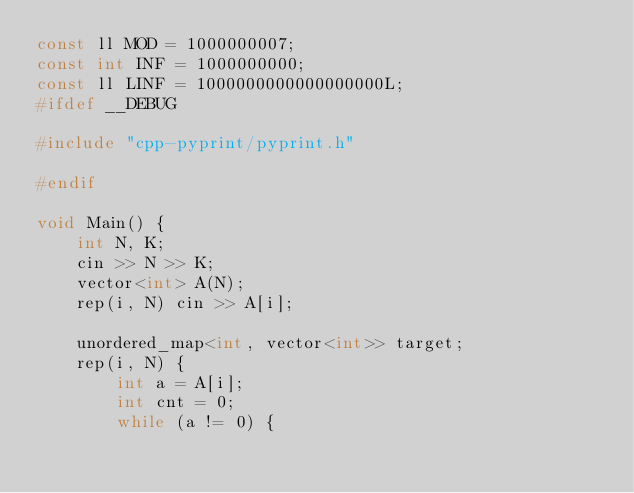<code> <loc_0><loc_0><loc_500><loc_500><_C++_>const ll MOD = 1000000007;
const int INF = 1000000000;
const ll LINF = 1000000000000000000L;
#ifdef __DEBUG

#include "cpp-pyprint/pyprint.h"

#endif

void Main() {
    int N, K;
    cin >> N >> K;
    vector<int> A(N);
    rep(i, N) cin >> A[i];

    unordered_map<int, vector<int>> target;
    rep(i, N) {
        int a = A[i];
        int cnt = 0;
        while (a != 0) {</code> 